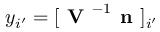Convert formula to latex. <formula><loc_0><loc_0><loc_500><loc_500>y _ { i ^ { \prime } } = [ V ^ { - 1 } n ] _ { i ^ { \prime } }</formula> 